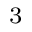<formula> <loc_0><loc_0><loc_500><loc_500>^ { 3 }</formula> 